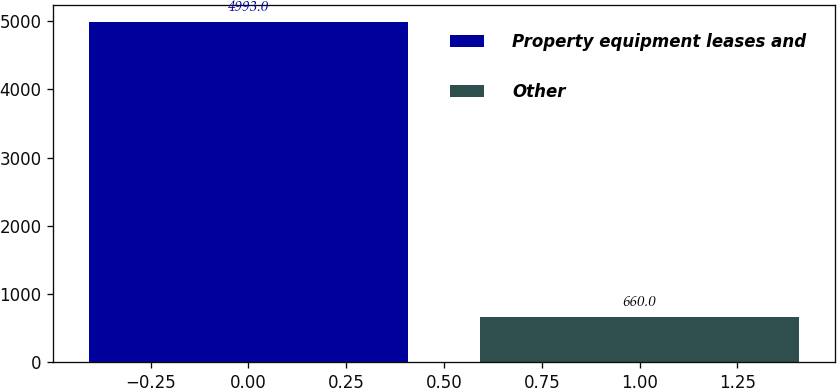<chart> <loc_0><loc_0><loc_500><loc_500><bar_chart><fcel>Property equipment leases and<fcel>Other<nl><fcel>4993<fcel>660<nl></chart> 